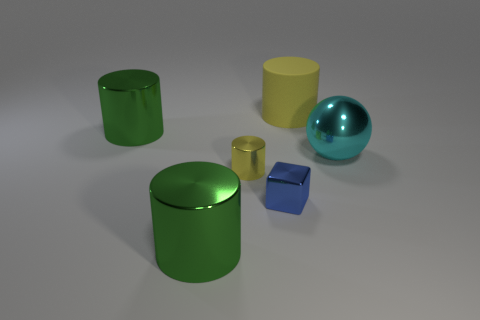Is there anything else that has the same material as the large yellow thing?
Your answer should be very brief. No. There is a yellow object that is on the left side of the matte cylinder; does it have the same shape as the shiny object on the right side of the small shiny block?
Your answer should be very brief. No. How many objects are tiny blue matte cylinders or blue things?
Offer a very short reply. 1. There is another yellow object that is the same shape as the large yellow thing; what is its size?
Keep it short and to the point. Small. Are there more blue metallic cubes to the left of the small yellow metallic thing than cyan objects?
Keep it short and to the point. No. Are the small blue block and the large cyan sphere made of the same material?
Your answer should be compact. Yes. How many things are green shiny cylinders that are in front of the tiny cylinder or objects on the left side of the yellow matte cylinder?
Offer a very short reply. 4. There is a big matte object that is the same shape as the yellow metal thing; what is its color?
Keep it short and to the point. Yellow. How many other small things have the same color as the matte thing?
Your answer should be compact. 1. Is the color of the metal cube the same as the ball?
Ensure brevity in your answer.  No. 